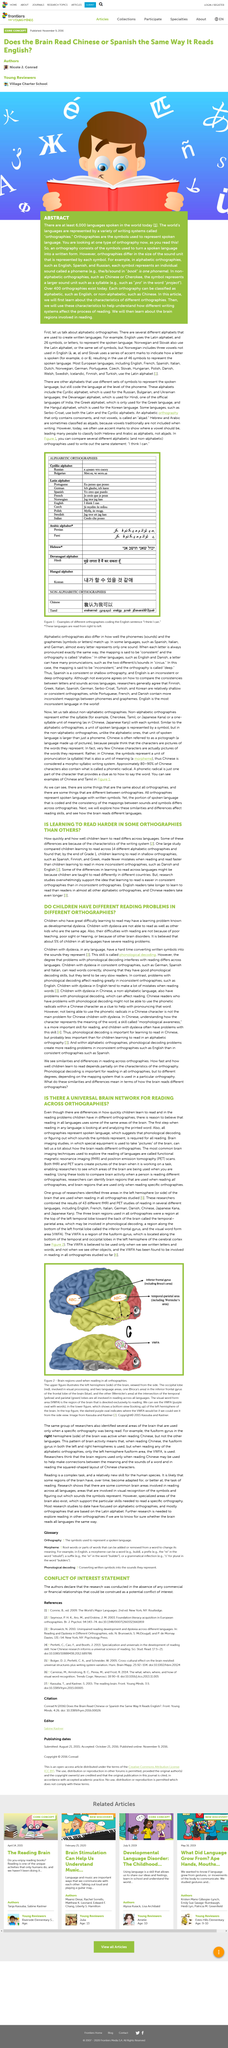Highlight a few significant elements in this photo. Children with dyslexia are not able to read as well as their same-age peers. This article is about the topic of children's reading problems and their causes. 